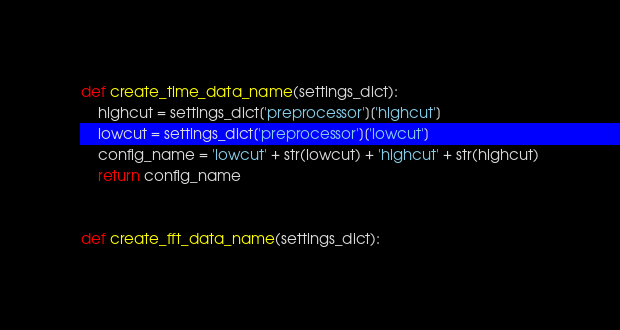Convert code to text. <code><loc_0><loc_0><loc_500><loc_500><_Python_>def create_time_data_name(settings_dict):
    highcut = settings_dict['preprocessor']['highcut']
    lowcut = settings_dict['preprocessor']['lowcut']
    config_name = 'lowcut' + str(lowcut) + 'highcut' + str(highcut)
    return config_name


def create_fft_data_name(settings_dict):</code> 